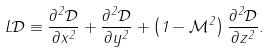<formula> <loc_0><loc_0><loc_500><loc_500>L { \mathcal { D } } \equiv \frac { \partial ^ { 2 } { \mathcal { D } } } { \partial x ^ { 2 } } + \frac { \partial ^ { 2 } { \mathcal { D } } } { \partial y ^ { 2 } } + \left ( 1 - { \mathcal { M } } ^ { 2 } \right ) \frac { \partial ^ { 2 } { \mathcal { D } } } { \partial z ^ { 2 } } .</formula> 